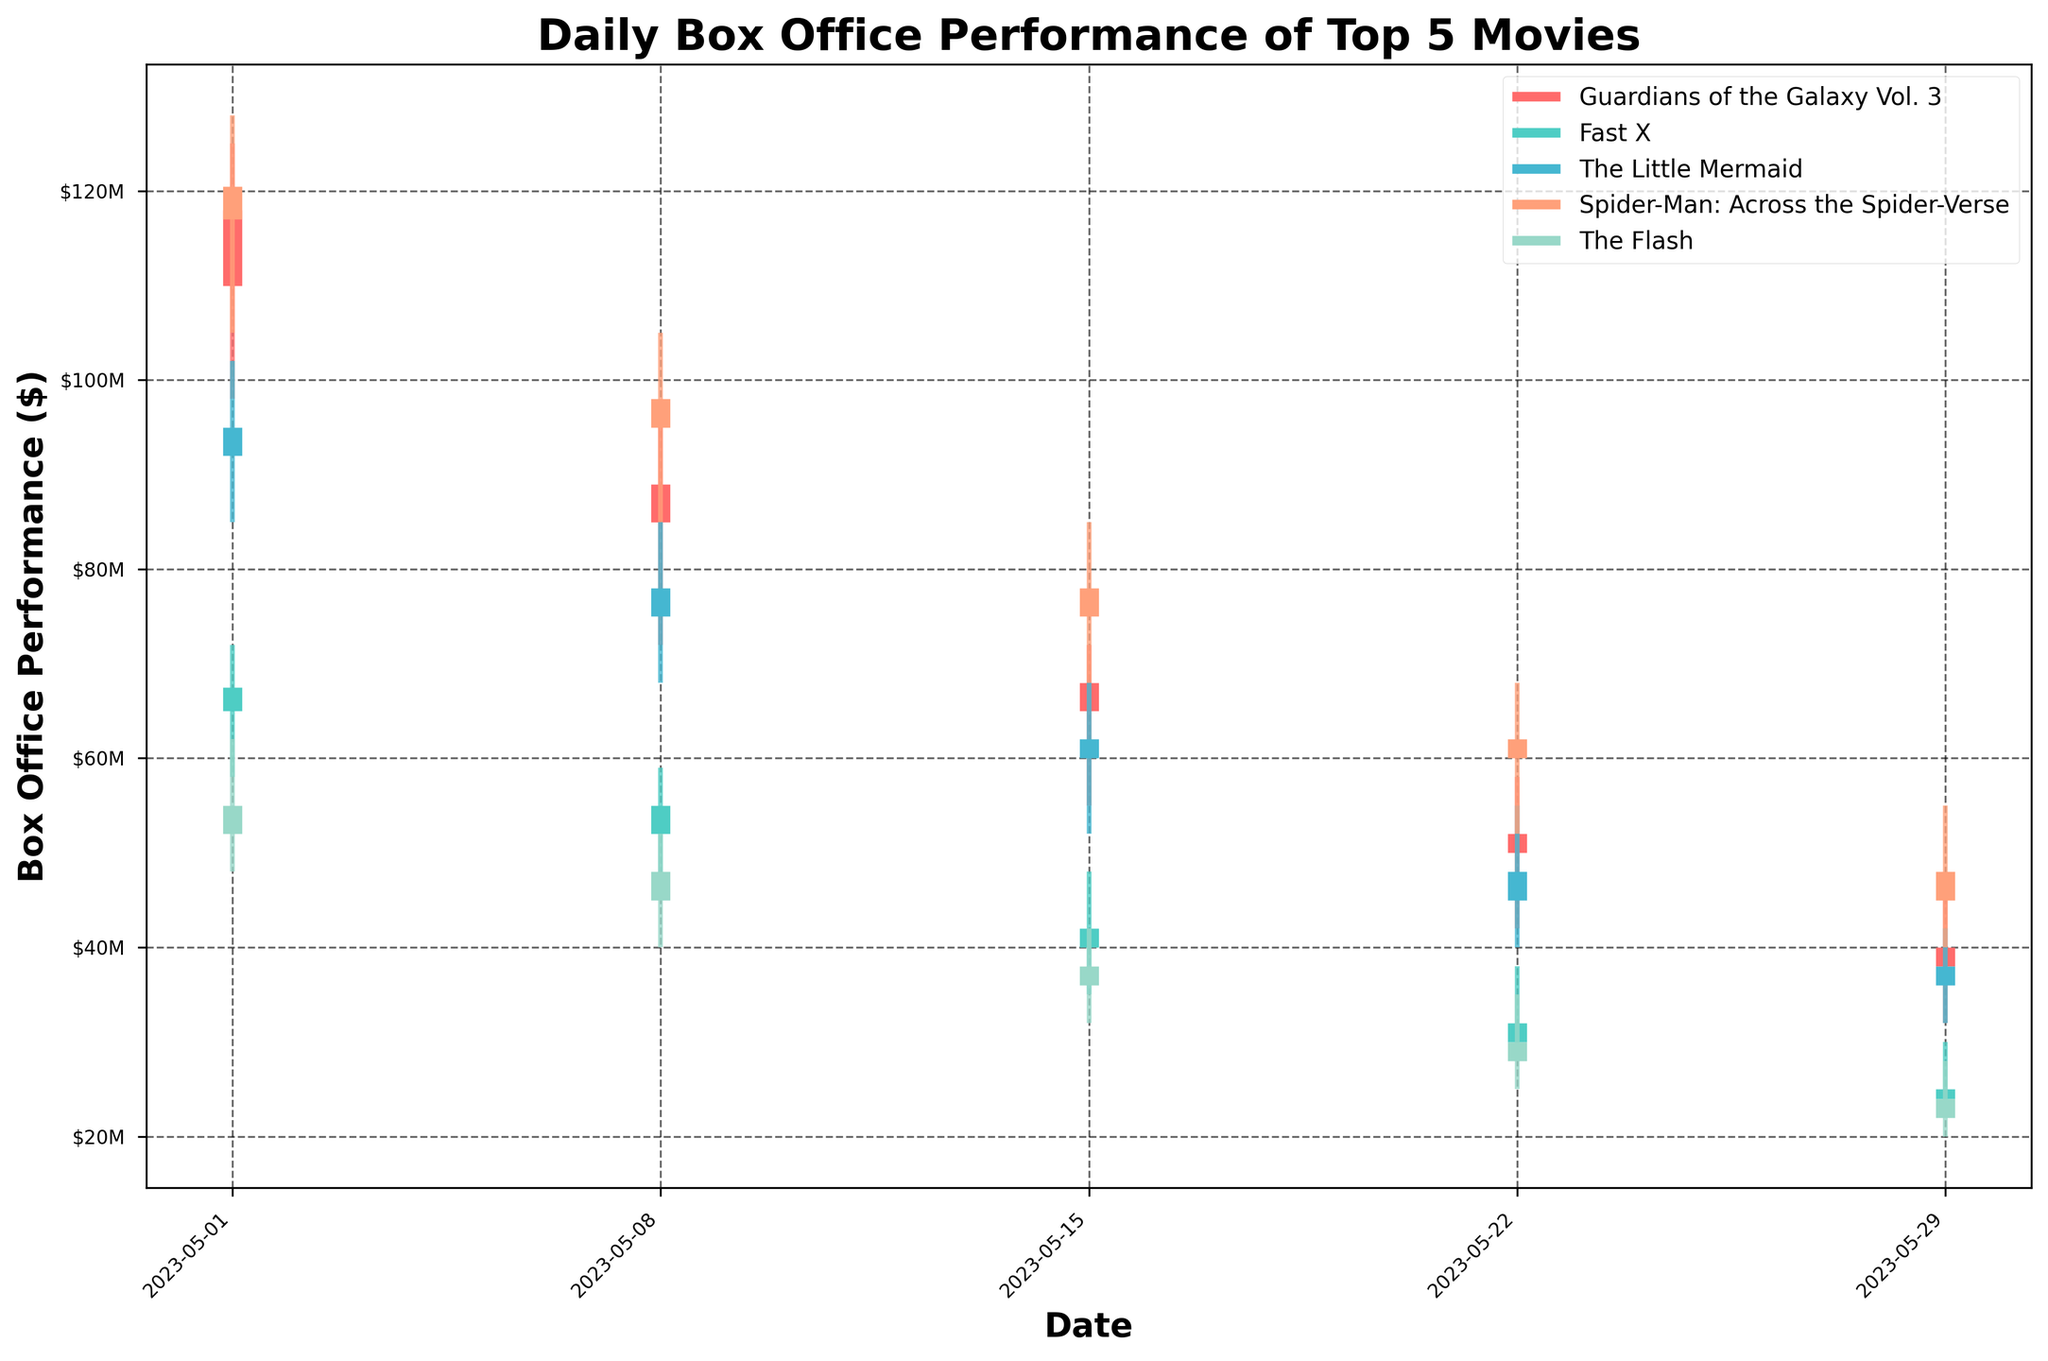What is the title of the figure? The title of the figure is usually placed at the top and is larger and bolder than other text elements on the figure. Here, it reads "Daily Box Office Performance of Top 5 Movies".
Answer: Daily Box Office Performance of Top 5 Movies Which movie had the highest daily opening box office sales? By examining the highest opening values of the five movies represented on the figure, we see that "Spider-Man: Across the Spider-Verse" had the highest opening box office sales on 2023-05-01 with $120.5M.
Answer: Spider-Man: Across the Spider-Verse On which date did "The Flash" have its lowest closing box office sales? By looking at the closing values for "The Flash" across all dates, we see the lowest closing value on 2023-05-29, where it closed at $22 million.
Answer: 2023-05-29 Which movie shows the largest high-to-low range on 2023-05-01? To find the largest high-to-low range, we subtract the low value from the high value for each movie on 2023-05-01, and compare them. "Spider-Man: Across the Spider-Verse" had the largest range: $128M (High) - $105M (Low) = $23M.
Answer: Spider-Man: Across the Spider-Verse What was the closing box office performance of "Fast X" on 2023-05-22? By examining the closing values, we find "Fast X" had a closing box office performance of $30 million on 2023-05-22.
Answer: $30 million What are the common visual elements used to represent each movie's daily box office performance? The visual elements include vertical lines representing the highest and lowest ticket sales (High and Low) with horizontal segments representing the opening and closing sales (Open and Close) for each movie on each date. Different colors are used to distinguish each movie.
Answer: Vertical and horizontal lines, colors Which movie had the steepest decline in closing box office sales from 2023-05-01 to 2023-05-29? By calculating the difference in closing values from 2023-05-01 to 2023-05-29 for each movie, we find "The Flash" had the steepest decline: $52M (2023-05-01) - $22M (2023-05-29) = $30M.
Answer: The Flash Compare the closing values of "The Little Mermaid" and "Guardians of the Galaxy Vol. 3" on 2023-05-15. Which one performed better? On 2023-05-15, "The Little Mermaid" had a closing box office of $60M while "Guardians of the Galaxy Vol. 3" had $65M. Therefore, "Guardians of the Galaxy Vol. 3" performed better.
Answer: Guardians of the Galaxy Vol. 3 What was the average closing box office performance of "Spider-Man: Across the Spider-Verse" over the month? To find the average, sum the closing values for each date (117M + 95M + 75M + 60M + 45M) = 392M, and divide by the number of dates (5). The average closing performance is $78.4M.
Answer: $78.4 million 